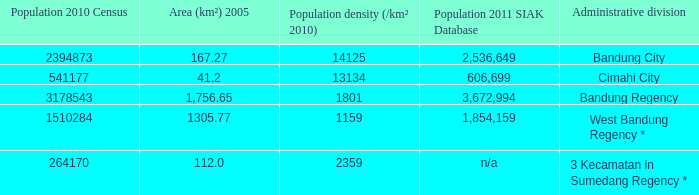What is the population density of bandung regency? 1801.0. 